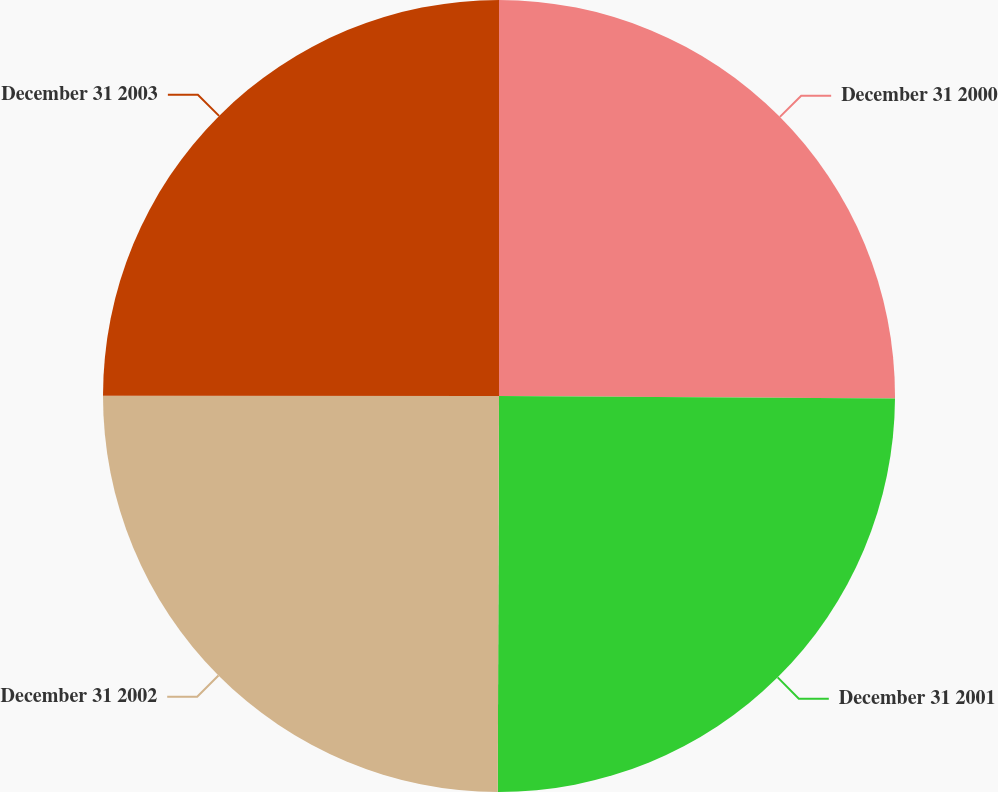<chart> <loc_0><loc_0><loc_500><loc_500><pie_chart><fcel>December 31 2000<fcel>December 31 2001<fcel>December 31 2002<fcel>December 31 2003<nl><fcel>25.1%<fcel>24.95%<fcel>24.96%<fcel>24.99%<nl></chart> 